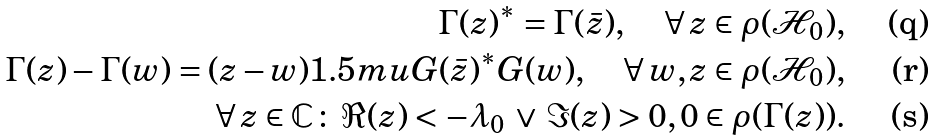<formula> <loc_0><loc_0><loc_500><loc_500>\Gamma ( z ) ^ { \ast } = \Gamma ( \bar { z } ) , \quad \forall \, z \in \rho ( \mathcal { H } _ { 0 } ) , \\ \Gamma ( z ) - \Gamma ( w ) = ( z - w ) { 1 . 5 m u } G ( \bar { z } ) ^ { \ast } G ( w ) , \quad \forall \, w , z \in \rho ( \mathcal { H } _ { 0 } ) , \\ \forall \, z \in \mathbb { C } \colon \, \Re ( z ) < - \lambda _ { 0 } \, \lor \, \Im ( z ) > 0 , 0 \in \rho ( \Gamma ( z ) ) .</formula> 